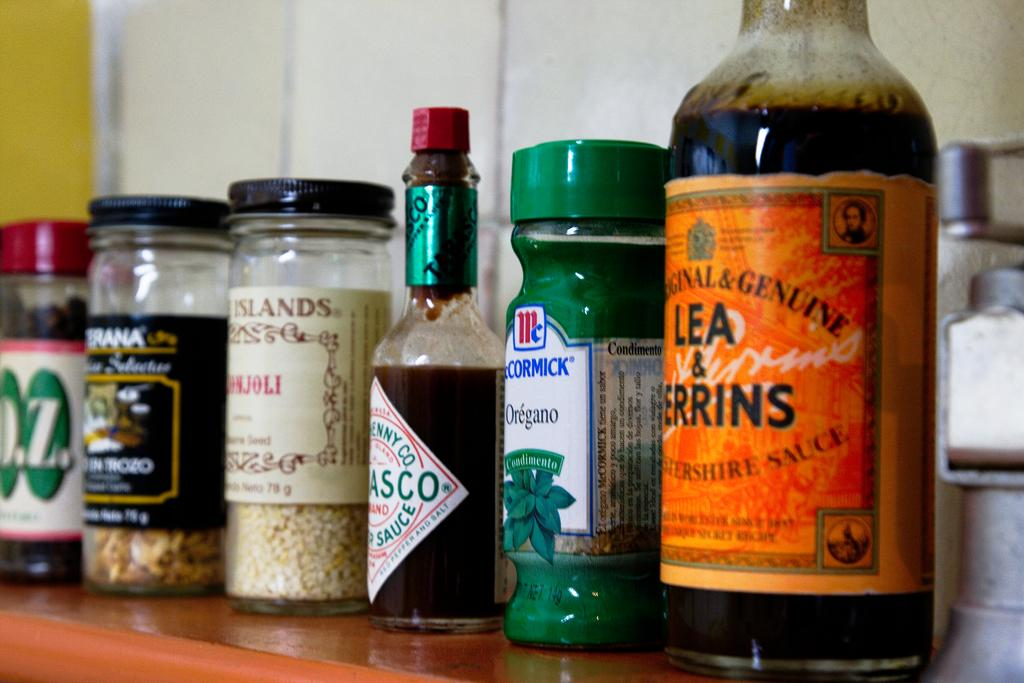<image>
Write a terse but informative summary of the picture. A variety of condiments and spices such as Tabasco, oregano, and Worcestershire sauce are lined up on a wooden shelf. 